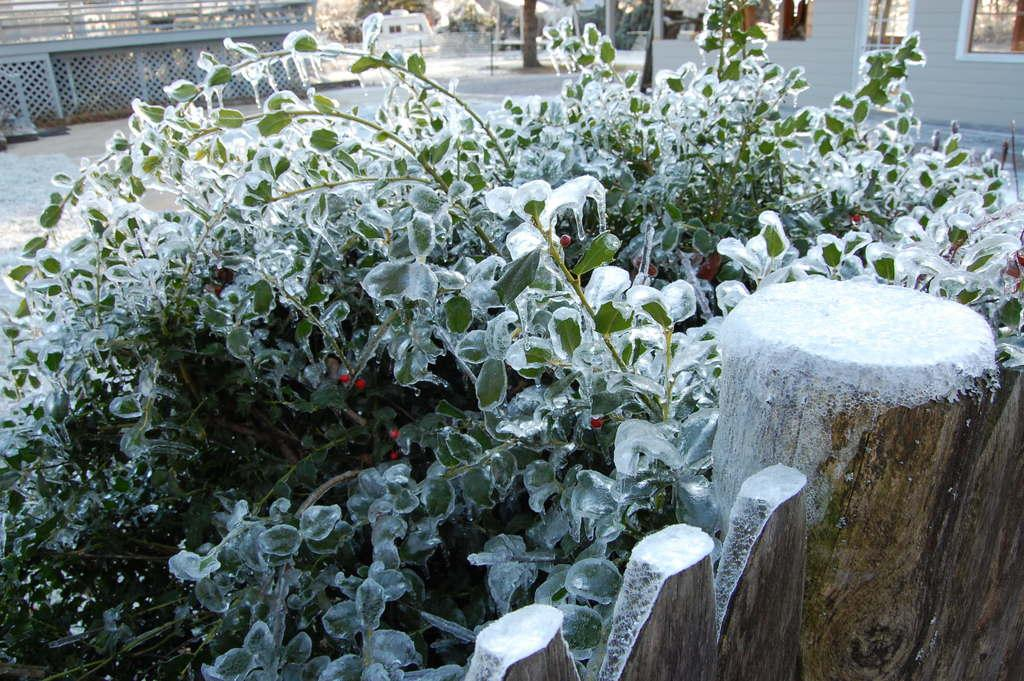What is the main object in the image? There is a huge wooden log in the image. What else can be seen in the image besides the wooden log? There are plants in the image, and ice is present on the plants. What can be seen in the background of the image? There is a building, railing, and trees in the background of the image. Can you see a farmer playing basketball on the swing in the image? No, there is no farmer, swing, or basketball present in the image. 